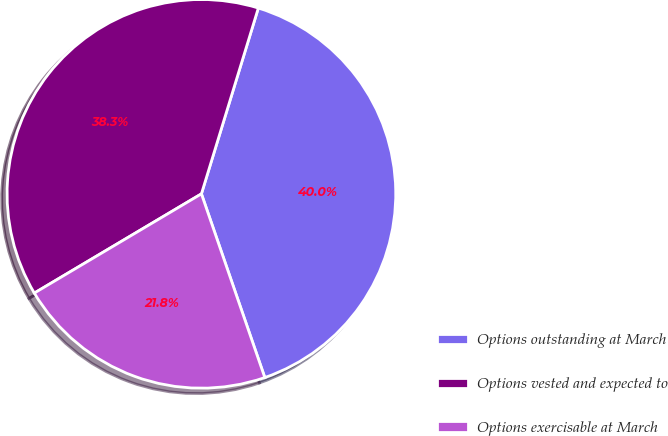Convert chart to OTSL. <chart><loc_0><loc_0><loc_500><loc_500><pie_chart><fcel>Options outstanding at March<fcel>Options vested and expected to<fcel>Options exercisable at March<nl><fcel>39.98%<fcel>38.26%<fcel>21.76%<nl></chart> 